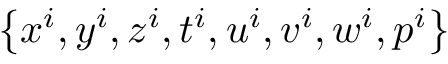<formula> <loc_0><loc_0><loc_500><loc_500>\left \{ x ^ { i } , y ^ { i } , z ^ { i } , t ^ { i } , u ^ { i } , v ^ { i } , w ^ { i } , p ^ { i } \right \}</formula> 